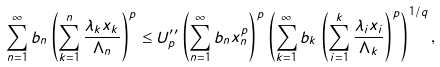Convert formula to latex. <formula><loc_0><loc_0><loc_500><loc_500>\sum ^ { \infty } _ { n = 1 } b _ { n } \left ( \sum ^ { n } _ { k = 1 } \frac { \lambda _ { k } x _ { k } } { \Lambda _ { n } } \right ) ^ { p } & \leq U ^ { \prime \prime } _ { p } \left ( \sum ^ { \infty } _ { n = 1 } b _ { n } x ^ { p } _ { n } \right ) ^ { p } \left ( \sum ^ { \infty } _ { k = 1 } b _ { k } \left ( \sum ^ { k } _ { i = 1 } \frac { \lambda _ { i } x _ { i } } { \Lambda _ { k } } \right ) ^ { p } \right ) ^ { 1 / q } ,</formula> 